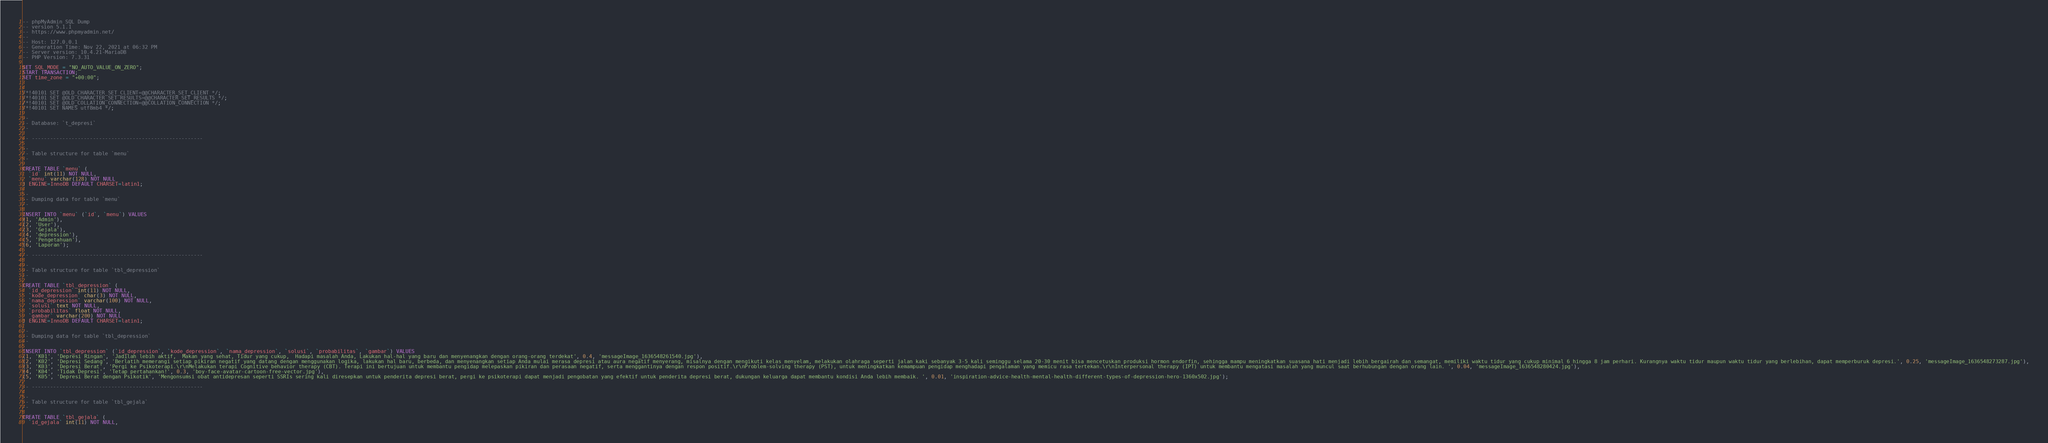<code> <loc_0><loc_0><loc_500><loc_500><_SQL_>-- phpMyAdmin SQL Dump
-- version 5.1.1
-- https://www.phpmyadmin.net/
--
-- Host: 127.0.0.1
-- Generation Time: Nov 22, 2021 at 06:32 PM
-- Server version: 10.4.21-MariaDB
-- PHP Version: 7.3.31

SET SQL_MODE = "NO_AUTO_VALUE_ON_ZERO";
START TRANSACTION;
SET time_zone = "+00:00";


/*!40101 SET @OLD_CHARACTER_SET_CLIENT=@@CHARACTER_SET_CLIENT */;
/*!40101 SET @OLD_CHARACTER_SET_RESULTS=@@CHARACTER_SET_RESULTS */;
/*!40101 SET @OLD_COLLATION_CONNECTION=@@COLLATION_CONNECTION */;
/*!40101 SET NAMES utf8mb4 */;

--
-- Database: `t_depresi`
--

-- --------------------------------------------------------

--
-- Table structure for table `menu`
--

CREATE TABLE `menu` (
  `id` int(11) NOT NULL,
  `menu` varchar(128) NOT NULL
) ENGINE=InnoDB DEFAULT CHARSET=latin1;

--
-- Dumping data for table `menu`
--

INSERT INTO `menu` (`id`, `menu`) VALUES
(1, 'Admin'),
(2, 'User'),
(3, 'Gejala'),
(4, 'depression'),
(5, 'Pengetahuan'),
(6, 'Laporan');

-- --------------------------------------------------------

--
-- Table structure for table `tbl_depression`
--

CREATE TABLE `tbl_depression` (
  `id_depression` int(11) NOT NULL,
  `kode_depression` char(3) NOT NULL,
  `nama_depression` varchar(100) NOT NULL,
  `solusi` text NOT NULL,
  `probabilitas` float NOT NULL,
  `gambar` varchar(200) NOT NULL
) ENGINE=InnoDB DEFAULT CHARSET=latin1;

--
-- Dumping data for table `tbl_depression`
--

INSERT INTO `tbl_depression` (`id_depression`, `kode_depression`, `nama_depression`, `solusi`, `probabilitas`, `gambar`) VALUES
(1, 'K01', 'Depresi Ringan', 'Jadilah lebih aktif,  Makan yang sehat, Tidur yang cukup,  Hadapi masalah Anda, Lakukan hal-hal yang baru dan menyenangkan dengan orang-orang terdekat', 0.4, 'messageImage_1636548261540.jpg'),
(2, 'K02', 'Depresi Sedang', 'Berlatih memerangi setiap pikiran negatif yang datang dengan menggunakan logika, lakukan hal baru, berbeda, dan menyenangkan setiap Anda mulai merasa depresi atau aura negatif menyerang, misalnya dengan mengikuti kelas menyelam, melakukan olahraga seperti jalan kaki sebanyak 3-5 kali seminggu selama 20-30 menit bisa mencetuskan produksi hormon endorfin, sehingga mampu meningkatkan suasana hati menjadi lebih bergairah dan semangat, memiliki waktu tidur yang cukup minimal 6 hingga 8 jam perhari. Kurangnya waktu tidur maupun waktu tidur yang berlebihan, dapat memperburuk depresi.', 0.25, 'messageImage_1636548273287.jpg'),
(3, 'K03', 'Depresi Berat', 'Pergi ke Psikoterapi.\r\nMelakukan terapi Cognitive behavior therapy (CBT). Terapi ini bertujuan untuk membantu pengidap melepaskan pikiran dan perasaan negatif, serta menggantinya dengan respon positif.\r\nProblem-solving therapy (PST), untuk meningkatkan kemampuan pengidap menghadapi pengalaman yang memicu rasa tertekan.\r\nInterpersonal therapy (IPT) untuk membantu mengatasi masalah yang muncul saat berhubungan dengan orang lain. ', 0.04, 'messageImage_1636548280424.jpg'),
(4, 'K04', 'Tidak Depresi', 'Tetap pertahankan!', 0.3, 'boy-face-avatar-cartoon-free-vector.jpg'),
(5, 'K05', 'Depresi Berat dengan Psikotik', 'Mengonsumsi obat antidepresan seperti SSRIs sering kali diresepkan untuk penderita depresi berat, pergi ke psikoterapi dapat menjadi pengobatan yang efektif untuk penderita depresi berat, dukungan keluarga dapat membantu kondisi Anda lebih membaik. ', 0.01, 'inspiration-advice-health-mental-health-different-types-of-depression-hero-1360x502.jpg');

-- --------------------------------------------------------

--
-- Table structure for table `tbl_gejala`
--

CREATE TABLE `tbl_gejala` (
  `id_gejala` int(11) NOT NULL,</code> 